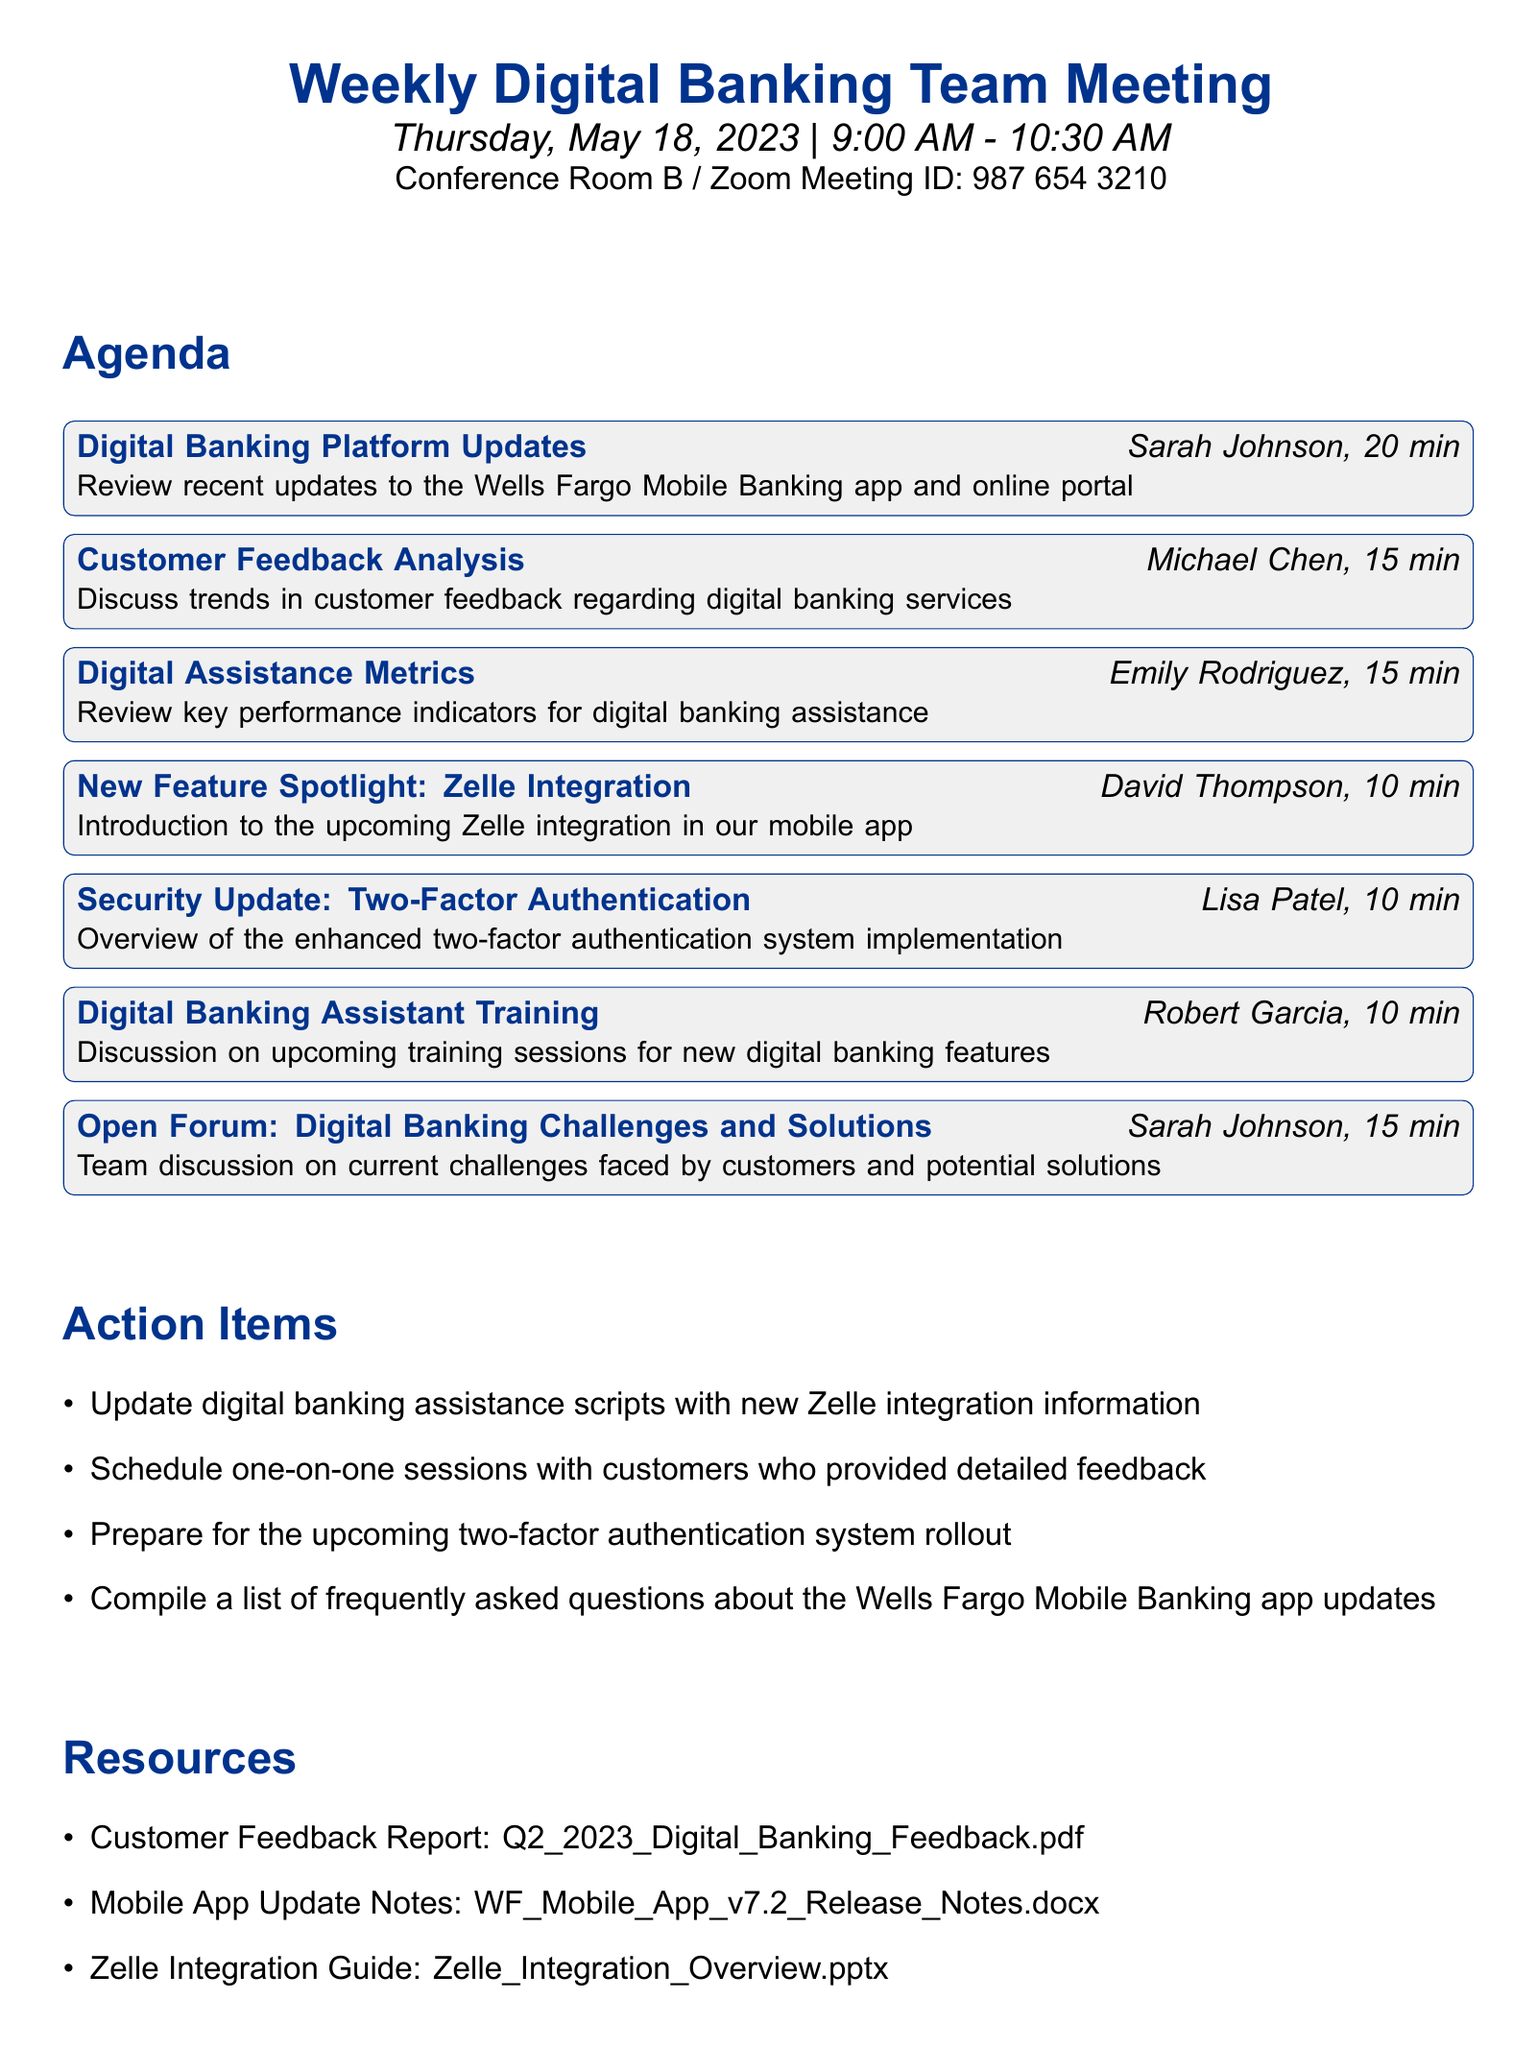What is the title of the meeting? The title is clearly stated at the beginning of the document as "Weekly Digital Banking Team Meeting."
Answer: Weekly Digital Banking Team Meeting Who is presenting the "Customer Feedback Analysis"? The document lists Michael Chen as the presenter for this agenda item.
Answer: Michael Chen What time does the meeting start? The start time is mentioned in the meeting details section and is listed as 9:00 AM.
Answer: 9:00 AM How long is the "Security Update: Two-Factor Authentication" scheduled for? The duration for this item is specified as 10 minutes in the agenda.
Answer: 10 minutes What is one of the action items discussed in the meeting? The document lists several action items, one of which is to "Update digital banking assistance scripts with new Zelle integration information."
Answer: Update digital banking assistance scripts with new Zelle integration information What is the location of the meeting? The location is clearly indicated in the meeting details section as "Conference Room B / Zoom Meeting ID: 987 654 3210."
Answer: Conference Room B / Zoom Meeting ID: 987 654 3210 Who is responsible for the "Digital Banking Assistant Training" agenda item? Robert Garcia is identified as the presenter of this specific agenda item.
Answer: Robert Garcia Which agenda item is associated with David Thompson? The document indicates that David Thompson is presenting the "New Feature Spotlight: Zelle Integration."
Answer: New Feature Spotlight: Zelle Integration 